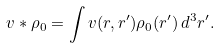<formula> <loc_0><loc_0><loc_500><loc_500>v * \rho _ { 0 } = \int v ( r , r ^ { \prime } ) \rho _ { 0 } ( r ^ { \prime } ) \, d ^ { 3 } r ^ { \prime } .</formula> 